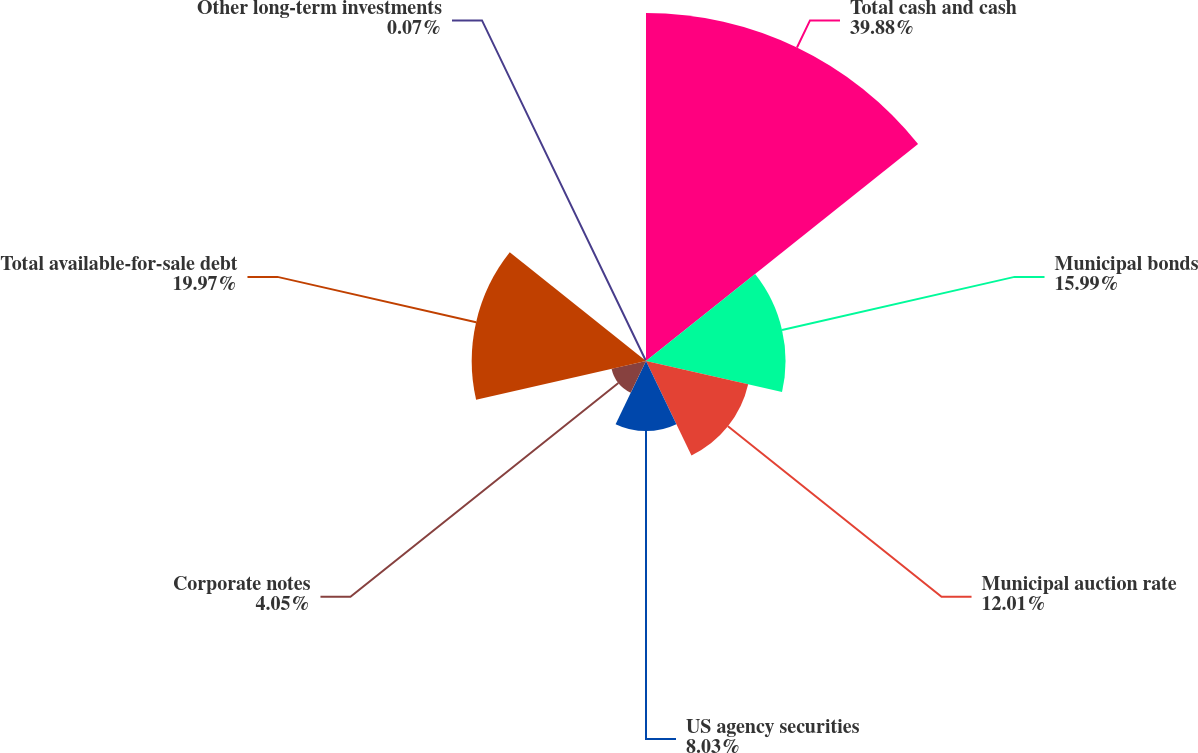Convert chart. <chart><loc_0><loc_0><loc_500><loc_500><pie_chart><fcel>Total cash and cash<fcel>Municipal bonds<fcel>Municipal auction rate<fcel>US agency securities<fcel>Corporate notes<fcel>Total available-for-sale debt<fcel>Other long-term investments<nl><fcel>39.88%<fcel>15.99%<fcel>12.01%<fcel>8.03%<fcel>4.05%<fcel>19.97%<fcel>0.07%<nl></chart> 